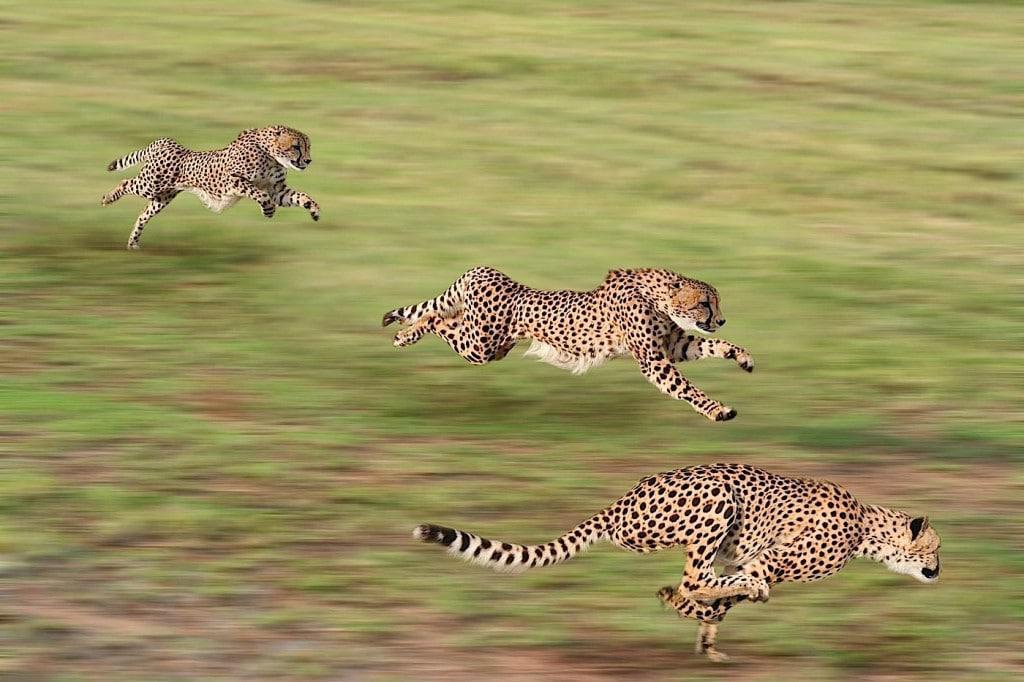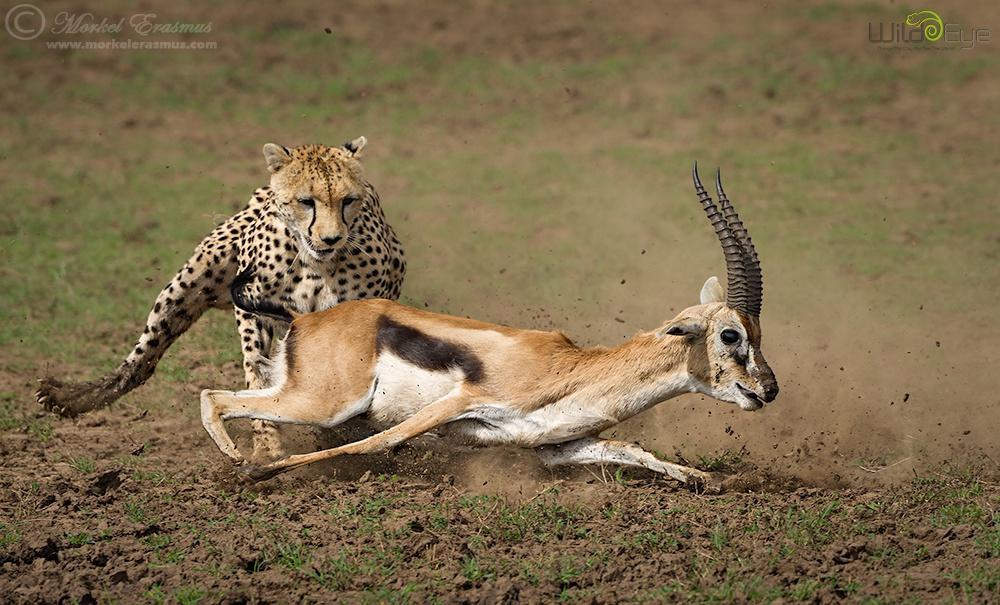The first image is the image on the left, the second image is the image on the right. Analyze the images presented: Is the assertion "In one image, a jaguar is hunting one single prey." valid? Answer yes or no. Yes. The first image is the image on the left, the second image is the image on the right. For the images shown, is this caption "There is a single cheetah pursuing a prey in the right image." true? Answer yes or no. Yes. 